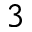<formula> <loc_0><loc_0><loc_500><loc_500>3</formula> 